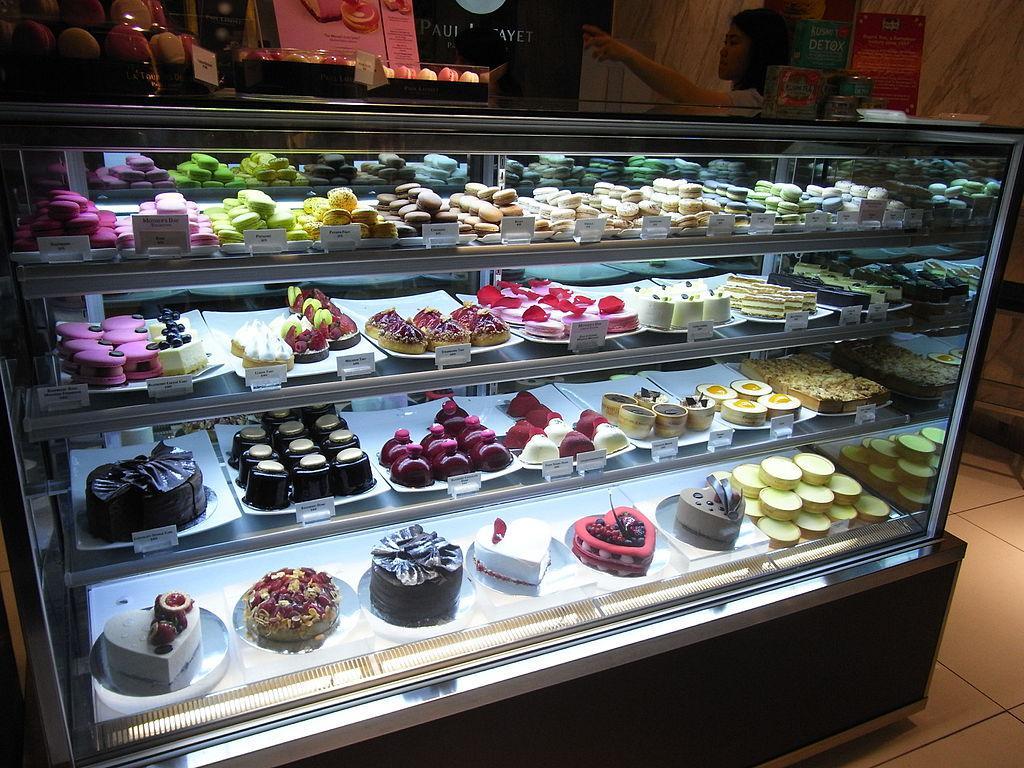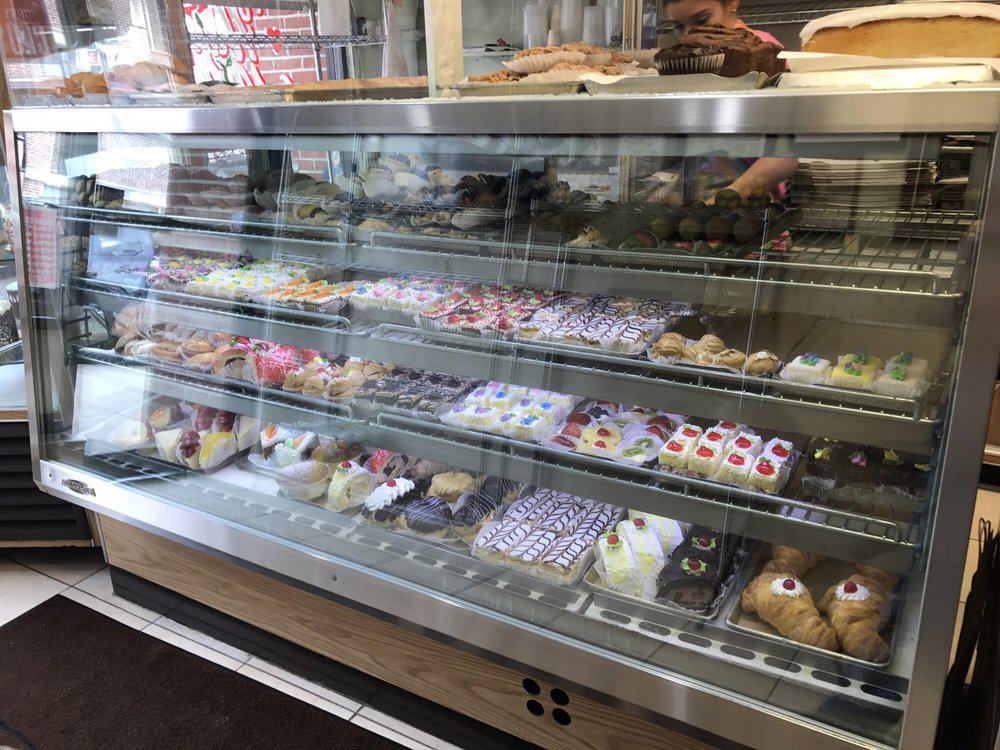The first image is the image on the left, the second image is the image on the right. Assess this claim about the two images: "Both displays contain three shelves.". Correct or not? Answer yes or no. No. 